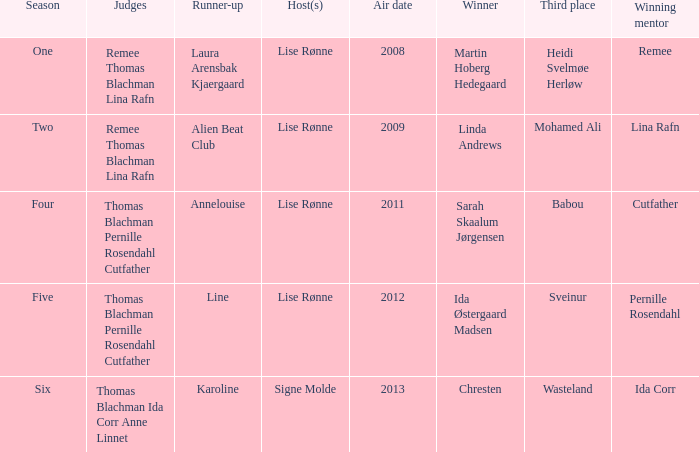Which season did Ida Corr win? Six. 